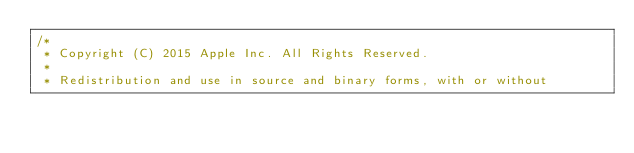<code> <loc_0><loc_0><loc_500><loc_500><_C++_>/*
 * Copyright (C) 2015 Apple Inc. All Rights Reserved.
 *
 * Redistribution and use in source and binary forms, with or without</code> 